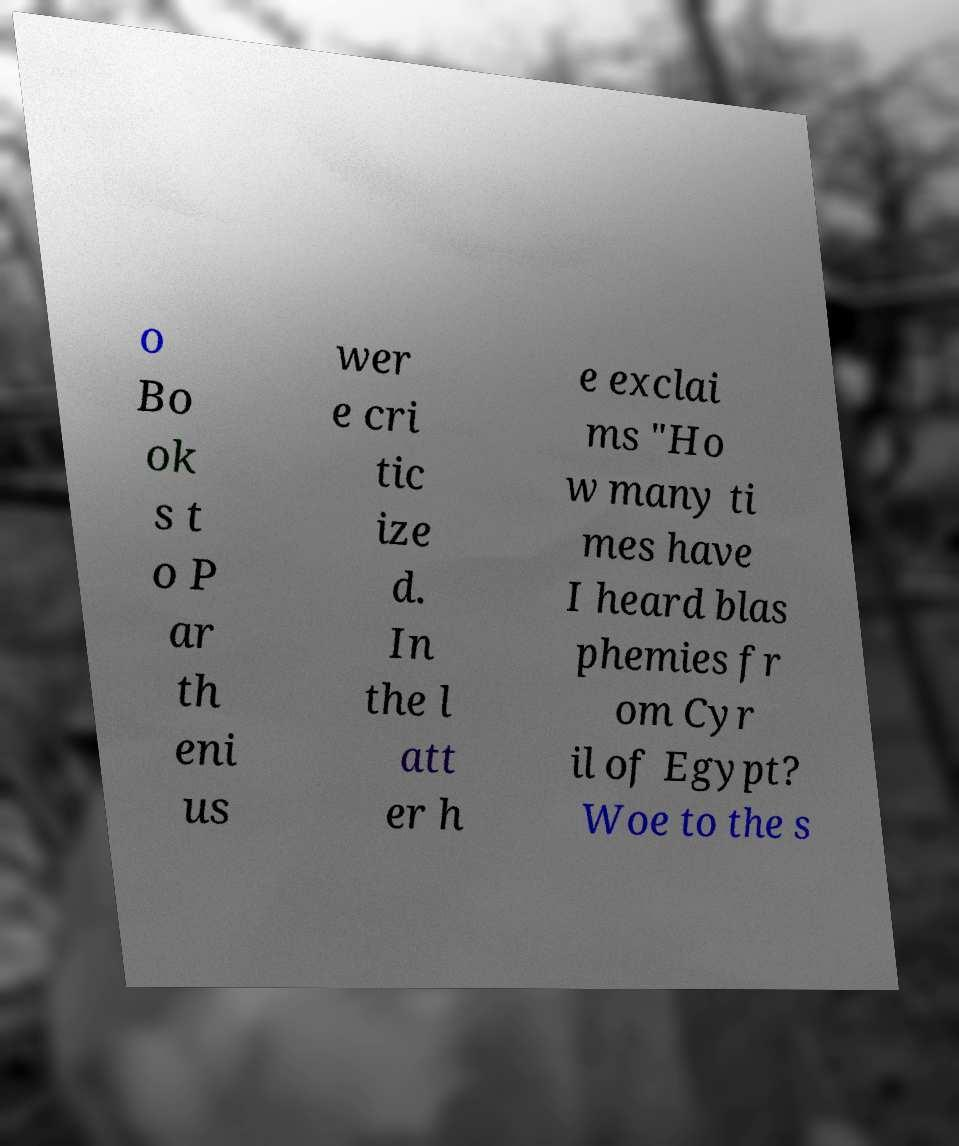Could you assist in decoding the text presented in this image and type it out clearly? o Bo ok s t o P ar th eni us wer e cri tic ize d. In the l att er h e exclai ms "Ho w many ti mes have I heard blas phemies fr om Cyr il of Egypt? Woe to the s 